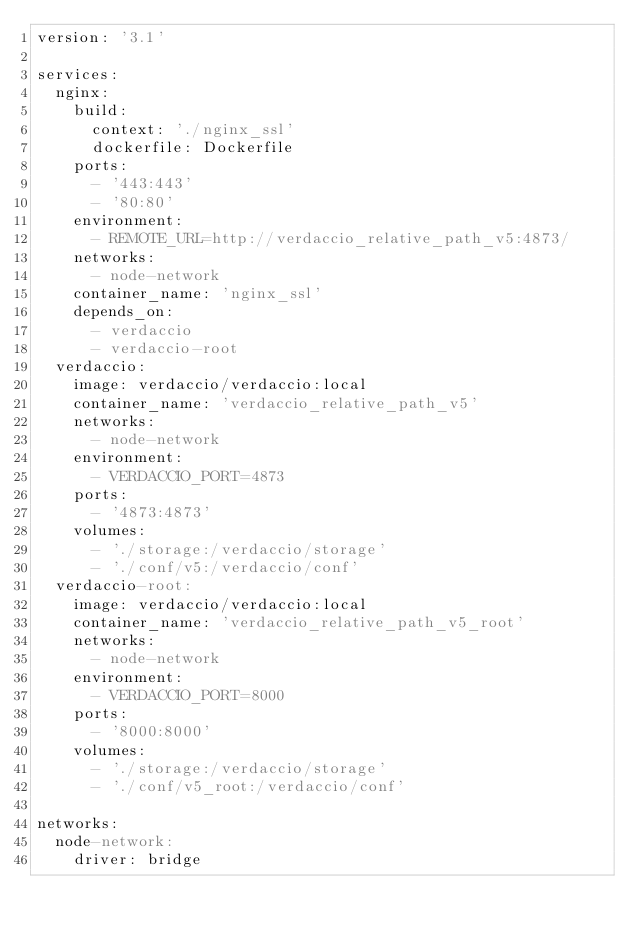Convert code to text. <code><loc_0><loc_0><loc_500><loc_500><_YAML_>version: '3.1'

services:
  nginx:
    build:
      context: './nginx_ssl'
      dockerfile: Dockerfile
    ports:
      - '443:443'
      - '80:80'
    environment:
      - REMOTE_URL=http://verdaccio_relative_path_v5:4873/
    networks:
      - node-network
    container_name: 'nginx_ssl'
    depends_on:
      - verdaccio
      - verdaccio-root
  verdaccio:
    image: verdaccio/verdaccio:local
    container_name: 'verdaccio_relative_path_v5'
    networks:
      - node-network
    environment:
      - VERDACCIO_PORT=4873
    ports:
      - '4873:4873'
    volumes:
      - './storage:/verdaccio/storage'
      - './conf/v5:/verdaccio/conf'
  verdaccio-root:
    image: verdaccio/verdaccio:local
    container_name: 'verdaccio_relative_path_v5_root'
    networks:
      - node-network
    environment:
      - VERDACCIO_PORT=8000
    ports:
      - '8000:8000'
    volumes:
      - './storage:/verdaccio/storage'
      - './conf/v5_root:/verdaccio/conf'

networks:
  node-network:
    driver: bridge
</code> 